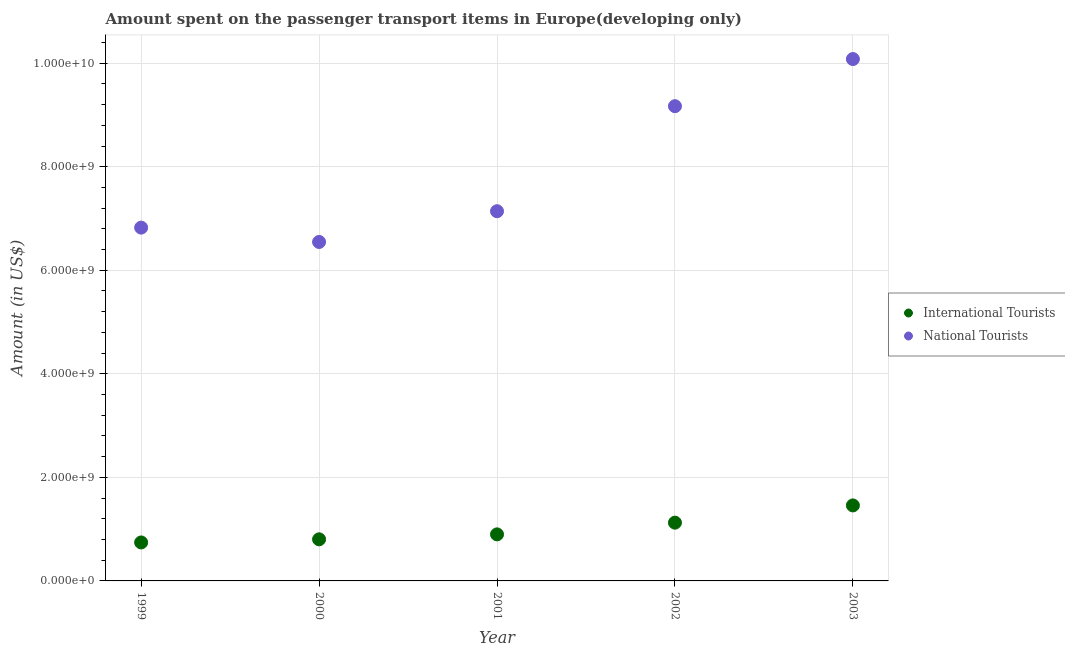Is the number of dotlines equal to the number of legend labels?
Ensure brevity in your answer.  Yes. What is the amount spent on transport items of national tourists in 2001?
Keep it short and to the point. 7.14e+09. Across all years, what is the maximum amount spent on transport items of international tourists?
Your answer should be very brief. 1.46e+09. Across all years, what is the minimum amount spent on transport items of national tourists?
Your answer should be very brief. 6.55e+09. In which year was the amount spent on transport items of international tourists maximum?
Your answer should be compact. 2003. What is the total amount spent on transport items of international tourists in the graph?
Make the answer very short. 5.03e+09. What is the difference between the amount spent on transport items of international tourists in 2001 and that in 2002?
Ensure brevity in your answer.  -2.26e+08. What is the difference between the amount spent on transport items of national tourists in 2002 and the amount spent on transport items of international tourists in 2000?
Offer a terse response. 8.37e+09. What is the average amount spent on transport items of international tourists per year?
Provide a short and direct response. 1.01e+09. In the year 2000, what is the difference between the amount spent on transport items of international tourists and amount spent on transport items of national tourists?
Your answer should be compact. -5.74e+09. What is the ratio of the amount spent on transport items of national tourists in 2000 to that in 2001?
Offer a terse response. 0.92. Is the difference between the amount spent on transport items of national tourists in 1999 and 2000 greater than the difference between the amount spent on transport items of international tourists in 1999 and 2000?
Provide a short and direct response. Yes. What is the difference between the highest and the second highest amount spent on transport items of national tourists?
Offer a terse response. 9.10e+08. What is the difference between the highest and the lowest amount spent on transport items of national tourists?
Make the answer very short. 3.53e+09. Is the sum of the amount spent on transport items of international tourists in 2001 and 2003 greater than the maximum amount spent on transport items of national tourists across all years?
Offer a very short reply. No. Does the amount spent on transport items of national tourists monotonically increase over the years?
Your answer should be compact. No. Is the amount spent on transport items of international tourists strictly greater than the amount spent on transport items of national tourists over the years?
Give a very brief answer. No. Is the amount spent on transport items of international tourists strictly less than the amount spent on transport items of national tourists over the years?
Give a very brief answer. Yes. What is the difference between two consecutive major ticks on the Y-axis?
Make the answer very short. 2.00e+09. Does the graph contain grids?
Make the answer very short. Yes. How are the legend labels stacked?
Offer a very short reply. Vertical. What is the title of the graph?
Provide a succinct answer. Amount spent on the passenger transport items in Europe(developing only). What is the label or title of the Y-axis?
Your response must be concise. Amount (in US$). What is the Amount (in US$) of International Tourists in 1999?
Provide a succinct answer. 7.43e+08. What is the Amount (in US$) in National Tourists in 1999?
Offer a very short reply. 6.82e+09. What is the Amount (in US$) in International Tourists in 2000?
Offer a terse response. 8.04e+08. What is the Amount (in US$) in National Tourists in 2000?
Offer a very short reply. 6.55e+09. What is the Amount (in US$) in International Tourists in 2001?
Keep it short and to the point. 8.99e+08. What is the Amount (in US$) in National Tourists in 2001?
Your answer should be compact. 7.14e+09. What is the Amount (in US$) of International Tourists in 2002?
Give a very brief answer. 1.13e+09. What is the Amount (in US$) of National Tourists in 2002?
Make the answer very short. 9.17e+09. What is the Amount (in US$) of International Tourists in 2003?
Your answer should be very brief. 1.46e+09. What is the Amount (in US$) of National Tourists in 2003?
Provide a succinct answer. 1.01e+1. Across all years, what is the maximum Amount (in US$) of International Tourists?
Offer a terse response. 1.46e+09. Across all years, what is the maximum Amount (in US$) of National Tourists?
Give a very brief answer. 1.01e+1. Across all years, what is the minimum Amount (in US$) of International Tourists?
Offer a terse response. 7.43e+08. Across all years, what is the minimum Amount (in US$) of National Tourists?
Give a very brief answer. 6.55e+09. What is the total Amount (in US$) in International Tourists in the graph?
Ensure brevity in your answer.  5.03e+09. What is the total Amount (in US$) of National Tourists in the graph?
Ensure brevity in your answer.  3.98e+1. What is the difference between the Amount (in US$) of International Tourists in 1999 and that in 2000?
Your response must be concise. -6.04e+07. What is the difference between the Amount (in US$) of National Tourists in 1999 and that in 2000?
Provide a succinct answer. 2.77e+08. What is the difference between the Amount (in US$) in International Tourists in 1999 and that in 2001?
Give a very brief answer. -1.56e+08. What is the difference between the Amount (in US$) of National Tourists in 1999 and that in 2001?
Provide a short and direct response. -3.17e+08. What is the difference between the Amount (in US$) of International Tourists in 1999 and that in 2002?
Give a very brief answer. -3.82e+08. What is the difference between the Amount (in US$) of National Tourists in 1999 and that in 2002?
Keep it short and to the point. -2.35e+09. What is the difference between the Amount (in US$) of International Tourists in 1999 and that in 2003?
Keep it short and to the point. -7.15e+08. What is the difference between the Amount (in US$) in National Tourists in 1999 and that in 2003?
Provide a succinct answer. -3.26e+09. What is the difference between the Amount (in US$) of International Tourists in 2000 and that in 2001?
Make the answer very short. -9.55e+07. What is the difference between the Amount (in US$) of National Tourists in 2000 and that in 2001?
Ensure brevity in your answer.  -5.94e+08. What is the difference between the Amount (in US$) of International Tourists in 2000 and that in 2002?
Your answer should be very brief. -3.22e+08. What is the difference between the Amount (in US$) in National Tourists in 2000 and that in 2002?
Provide a short and direct response. -2.62e+09. What is the difference between the Amount (in US$) in International Tourists in 2000 and that in 2003?
Offer a very short reply. -6.55e+08. What is the difference between the Amount (in US$) in National Tourists in 2000 and that in 2003?
Provide a succinct answer. -3.53e+09. What is the difference between the Amount (in US$) in International Tourists in 2001 and that in 2002?
Your response must be concise. -2.26e+08. What is the difference between the Amount (in US$) in National Tourists in 2001 and that in 2002?
Make the answer very short. -2.03e+09. What is the difference between the Amount (in US$) of International Tourists in 2001 and that in 2003?
Offer a very short reply. -5.59e+08. What is the difference between the Amount (in US$) of National Tourists in 2001 and that in 2003?
Keep it short and to the point. -2.94e+09. What is the difference between the Amount (in US$) of International Tourists in 2002 and that in 2003?
Ensure brevity in your answer.  -3.33e+08. What is the difference between the Amount (in US$) in National Tourists in 2002 and that in 2003?
Your answer should be very brief. -9.10e+08. What is the difference between the Amount (in US$) in International Tourists in 1999 and the Amount (in US$) in National Tourists in 2000?
Offer a very short reply. -5.80e+09. What is the difference between the Amount (in US$) of International Tourists in 1999 and the Amount (in US$) of National Tourists in 2001?
Provide a short and direct response. -6.40e+09. What is the difference between the Amount (in US$) of International Tourists in 1999 and the Amount (in US$) of National Tourists in 2002?
Your answer should be very brief. -8.43e+09. What is the difference between the Amount (in US$) of International Tourists in 1999 and the Amount (in US$) of National Tourists in 2003?
Your answer should be compact. -9.34e+09. What is the difference between the Amount (in US$) in International Tourists in 2000 and the Amount (in US$) in National Tourists in 2001?
Ensure brevity in your answer.  -6.34e+09. What is the difference between the Amount (in US$) of International Tourists in 2000 and the Amount (in US$) of National Tourists in 2002?
Offer a terse response. -8.37e+09. What is the difference between the Amount (in US$) of International Tourists in 2000 and the Amount (in US$) of National Tourists in 2003?
Give a very brief answer. -9.28e+09. What is the difference between the Amount (in US$) of International Tourists in 2001 and the Amount (in US$) of National Tourists in 2002?
Provide a succinct answer. -8.27e+09. What is the difference between the Amount (in US$) of International Tourists in 2001 and the Amount (in US$) of National Tourists in 2003?
Make the answer very short. -9.18e+09. What is the difference between the Amount (in US$) in International Tourists in 2002 and the Amount (in US$) in National Tourists in 2003?
Keep it short and to the point. -8.95e+09. What is the average Amount (in US$) of International Tourists per year?
Give a very brief answer. 1.01e+09. What is the average Amount (in US$) of National Tourists per year?
Your answer should be very brief. 7.95e+09. In the year 1999, what is the difference between the Amount (in US$) of International Tourists and Amount (in US$) of National Tourists?
Keep it short and to the point. -6.08e+09. In the year 2000, what is the difference between the Amount (in US$) in International Tourists and Amount (in US$) in National Tourists?
Ensure brevity in your answer.  -5.74e+09. In the year 2001, what is the difference between the Amount (in US$) of International Tourists and Amount (in US$) of National Tourists?
Your answer should be very brief. -6.24e+09. In the year 2002, what is the difference between the Amount (in US$) of International Tourists and Amount (in US$) of National Tourists?
Keep it short and to the point. -8.04e+09. In the year 2003, what is the difference between the Amount (in US$) in International Tourists and Amount (in US$) in National Tourists?
Keep it short and to the point. -8.62e+09. What is the ratio of the Amount (in US$) in International Tourists in 1999 to that in 2000?
Give a very brief answer. 0.92. What is the ratio of the Amount (in US$) in National Tourists in 1999 to that in 2000?
Your answer should be compact. 1.04. What is the ratio of the Amount (in US$) in International Tourists in 1999 to that in 2001?
Offer a terse response. 0.83. What is the ratio of the Amount (in US$) of National Tourists in 1999 to that in 2001?
Provide a short and direct response. 0.96. What is the ratio of the Amount (in US$) in International Tourists in 1999 to that in 2002?
Provide a short and direct response. 0.66. What is the ratio of the Amount (in US$) of National Tourists in 1999 to that in 2002?
Provide a short and direct response. 0.74. What is the ratio of the Amount (in US$) of International Tourists in 1999 to that in 2003?
Give a very brief answer. 0.51. What is the ratio of the Amount (in US$) in National Tourists in 1999 to that in 2003?
Your response must be concise. 0.68. What is the ratio of the Amount (in US$) of International Tourists in 2000 to that in 2001?
Your answer should be very brief. 0.89. What is the ratio of the Amount (in US$) in National Tourists in 2000 to that in 2001?
Your answer should be compact. 0.92. What is the ratio of the Amount (in US$) of International Tourists in 2000 to that in 2002?
Give a very brief answer. 0.71. What is the ratio of the Amount (in US$) of National Tourists in 2000 to that in 2002?
Your answer should be compact. 0.71. What is the ratio of the Amount (in US$) in International Tourists in 2000 to that in 2003?
Provide a short and direct response. 0.55. What is the ratio of the Amount (in US$) in National Tourists in 2000 to that in 2003?
Offer a very short reply. 0.65. What is the ratio of the Amount (in US$) of International Tourists in 2001 to that in 2002?
Give a very brief answer. 0.8. What is the ratio of the Amount (in US$) in National Tourists in 2001 to that in 2002?
Your answer should be very brief. 0.78. What is the ratio of the Amount (in US$) in International Tourists in 2001 to that in 2003?
Your answer should be very brief. 0.62. What is the ratio of the Amount (in US$) of National Tourists in 2001 to that in 2003?
Provide a short and direct response. 0.71. What is the ratio of the Amount (in US$) in International Tourists in 2002 to that in 2003?
Give a very brief answer. 0.77. What is the ratio of the Amount (in US$) of National Tourists in 2002 to that in 2003?
Offer a terse response. 0.91. What is the difference between the highest and the second highest Amount (in US$) in International Tourists?
Ensure brevity in your answer.  3.33e+08. What is the difference between the highest and the second highest Amount (in US$) in National Tourists?
Your answer should be very brief. 9.10e+08. What is the difference between the highest and the lowest Amount (in US$) in International Tourists?
Ensure brevity in your answer.  7.15e+08. What is the difference between the highest and the lowest Amount (in US$) in National Tourists?
Provide a short and direct response. 3.53e+09. 